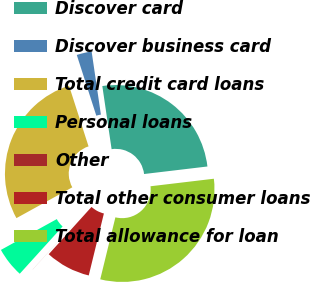<chart> <loc_0><loc_0><loc_500><loc_500><pie_chart><fcel>Discover card<fcel>Discover business card<fcel>Total credit card loans<fcel>Personal loans<fcel>Other<fcel>Total other consumer loans<fcel>Total allowance for loan<nl><fcel>25.44%<fcel>2.63%<fcel>28.07%<fcel>5.26%<fcel>0.01%<fcel>7.89%<fcel>30.7%<nl></chart> 